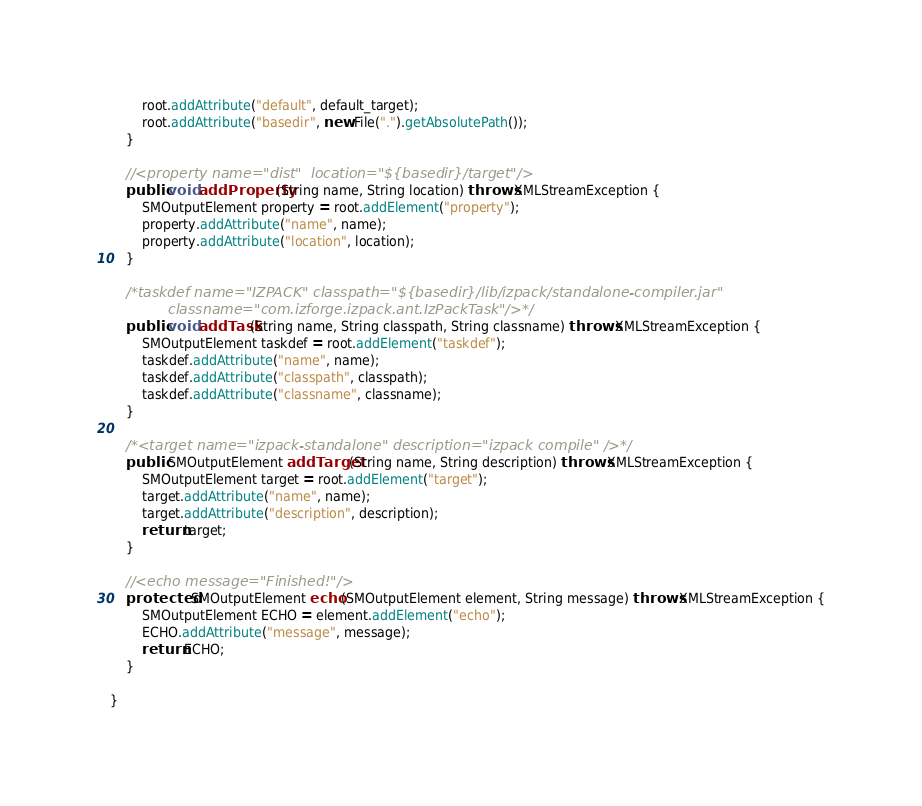Convert code to text. <code><loc_0><loc_0><loc_500><loc_500><_Java_>        root.addAttribute("default", default_target);
        root.addAttribute("basedir", new File(".").getAbsolutePath());
    }
    
    //<property name="dist"  location="${basedir}/target"/>
    public void addProperty(String name, String location) throws XMLStreamException {
        SMOutputElement property = root.addElement("property");
        property.addAttribute("name", name);
        property.addAttribute("location", location);
    }
    
    /*taskdef name="IZPACK" classpath="${basedir}/lib/izpack/standalone-compiler.jar"
             classname="com.izforge.izpack.ant.IzPackTask"/>*/
    public void addTask(String name, String classpath, String classname) throws XMLStreamException {
        SMOutputElement taskdef = root.addElement("taskdef");
        taskdef.addAttribute("name", name);
        taskdef.addAttribute("classpath", classpath);
        taskdef.addAttribute("classname", classname);
    }
    
    /*<target name="izpack-standalone" description="izpack compile" />*/
    public SMOutputElement addTarget(String name, String description) throws XMLStreamException {
        SMOutputElement target = root.addElement("target");
        target.addAttribute("name", name);
        target.addAttribute("description", description);
        return target;
    }
    
    //<echo message="Finished!"/>
    protected SMOutputElement echo(SMOutputElement element, String message) throws XMLStreamException {
        SMOutputElement ECHO = element.addElement("echo");
        ECHO.addAttribute("message", message);
        return ECHO;
    }
    
}
</code> 